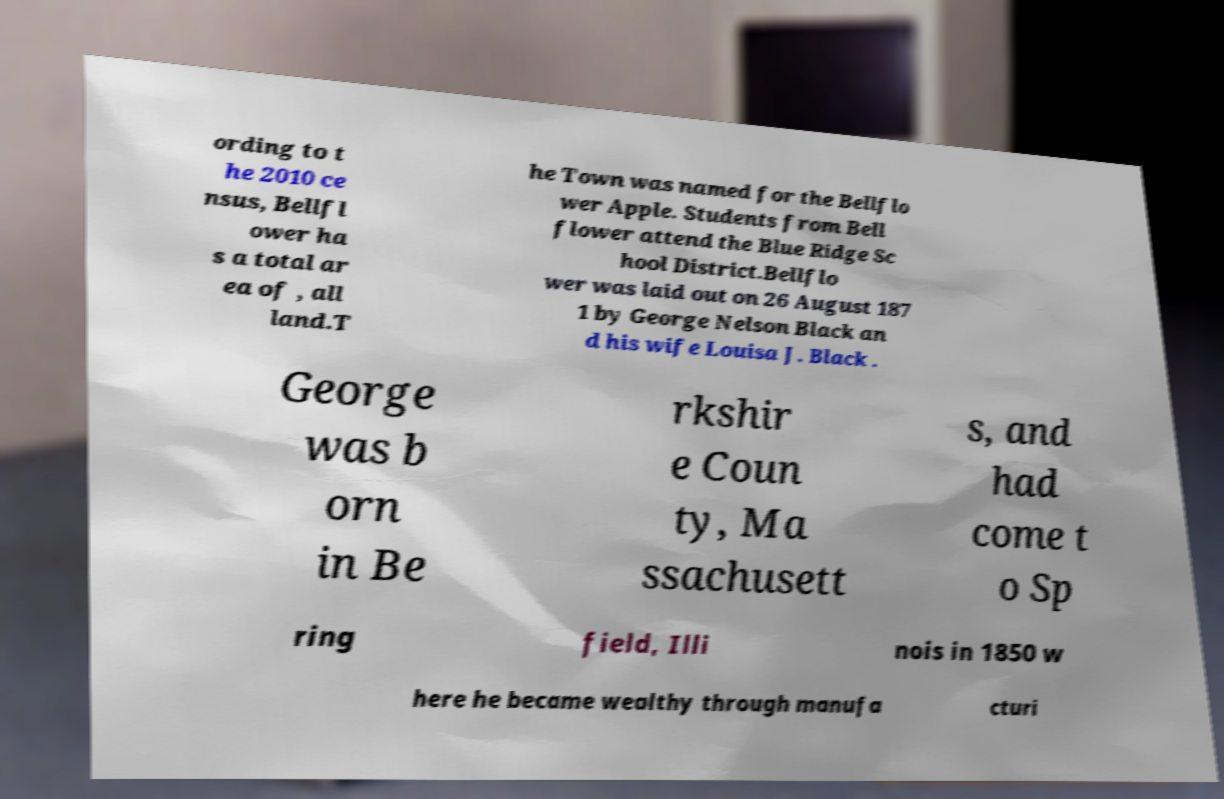Could you extract and type out the text from this image? ording to t he 2010 ce nsus, Bellfl ower ha s a total ar ea of , all land.T he Town was named for the Bellflo wer Apple. Students from Bell flower attend the Blue Ridge Sc hool District.Bellflo wer was laid out on 26 August 187 1 by George Nelson Black an d his wife Louisa J. Black . George was b orn in Be rkshir e Coun ty, Ma ssachusett s, and had come t o Sp ring field, Illi nois in 1850 w here he became wealthy through manufa cturi 